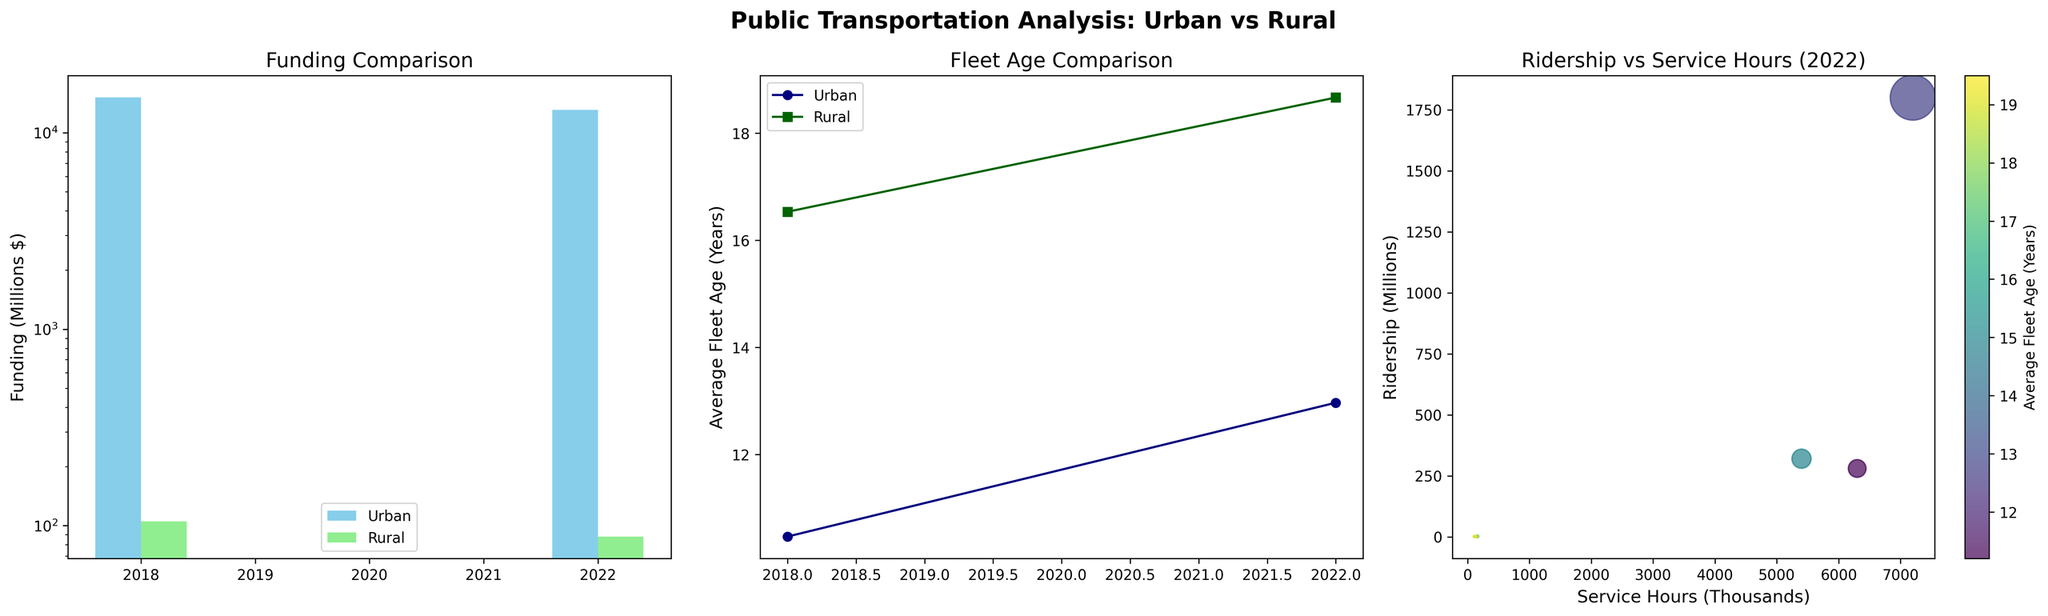How do the funding amounts in urban areas compare between 2018 and 2022? By looking at the first subplot titled "Funding Comparison," we can see that the bars for urban areas (represented in sky blue) are taller in 2018 compared to 2022, indicating a decrease in funding. Adding up the bar heights for urban areas in 2018 (New York City, Chicago, Los Angeles) and comparing them to the summed heights in 2022 confirms this observation.
Answer: Funding decreased in urban areas from 2018 to 2022 What is the average age of the fleet in rural areas in 2022? Referring to the subplot titled "Fleet Age Comparison," look at the data points for rural areas in 2022. The average value for the rural areas is represented by the dark green line marker in 2022, which shows an average age around 18.67 years.
Answer: Approximately 18.67 years Which area had the highest ridership in 2022? Refer to the third subplot titled "Ridership vs Service Hours (2022)." By examining the y-axis (Ridership in Millions), New York City has the highest data point at the top of the plot.
Answer: New York City Is the average age of the fleet in urban areas trending upwards or downwards? By observing the second subplot titled "Fleet Age Comparison," the line for urban areas (navy blue) shows a clear upward trend from 2018 to 2022.
Answer: Upwards How does ridership correlate with service hours in 2022? In the scatter plot titled "Ridership vs Service Hours (2022)," we can observe a generally positive correlation between service hours and ridership, indicating that higher service hours tend to result in higher ridership.
Answer: Positive correlation Did rural funding increase or decrease from 2018 to 2022? Looking at the first subplot titled "Funding Comparison," observe the light green bars representing rural funding. The heights of these bars indicate that rural funding decreased from 2018 to 2022.
Answer: Decreased How does the average fleet age in urban areas compare to rural areas in 2022? In the "Fleet Age Comparison" subplot, we see that the navy blue line (urban areas) has a lower value compared to the dark green line (rural areas) for 2022, indicating that the average fleet age is lower in urban areas in 2022.
Answer: Urban areas have a lower average fleet age Which year had more urban service hours? For urban service hours, check the third subplot titled "Ridership vs Service Hours (2022)." Urban areas are not explicitly labeled, but New York City, Chicago, and Los Angeles locations can be inferred from their higher values. Summing up service hours showed that 2018 had more urban service hours than 2022 overall.
Answer: 2018 had more urban service hours How is the average fleet age visually differentiated between urban and rural areas? Distinguish the navy line for urban areas and the dark green dots for rural areas in the "Fleet Age Comparison" plot. This color scheme helps in quickly understanding the respective fleet ages.
Answer: Navy for urban areas and dark green for rural areas 